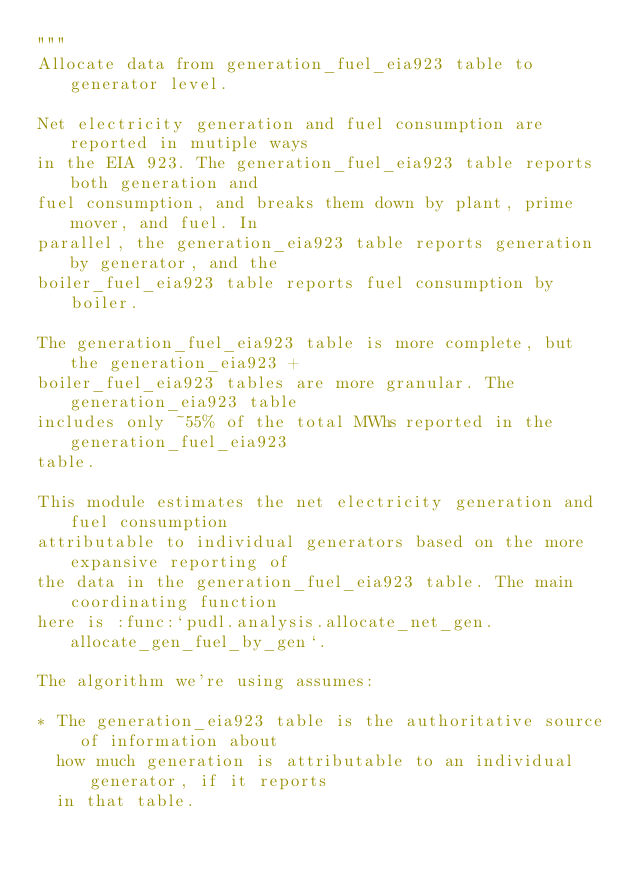<code> <loc_0><loc_0><loc_500><loc_500><_Python_>"""
Allocate data from generation_fuel_eia923 table to generator level.

Net electricity generation and fuel consumption are reported in mutiple ways
in the EIA 923. The generation_fuel_eia923 table reports both generation and
fuel consumption, and breaks them down by plant, prime mover, and fuel. In
parallel, the generation_eia923 table reports generation by generator, and the
boiler_fuel_eia923 table reports fuel consumption by boiler.

The generation_fuel_eia923 table is more complete, but the generation_eia923 +
boiler_fuel_eia923 tables are more granular. The generation_eia923 table
includes only ~55% of the total MWhs reported in the generation_fuel_eia923
table.

This module estimates the net electricity generation and fuel consumption
attributable to individual generators based on the more expansive reporting of
the data in the generation_fuel_eia923 table. The main coordinating function
here is :func:`pudl.analysis.allocate_net_gen.allocate_gen_fuel_by_gen`.

The algorithm we're using assumes:

* The generation_eia923 table is the authoritative source of information about
  how much generation is attributable to an individual generator, if it reports
  in that table.</code> 